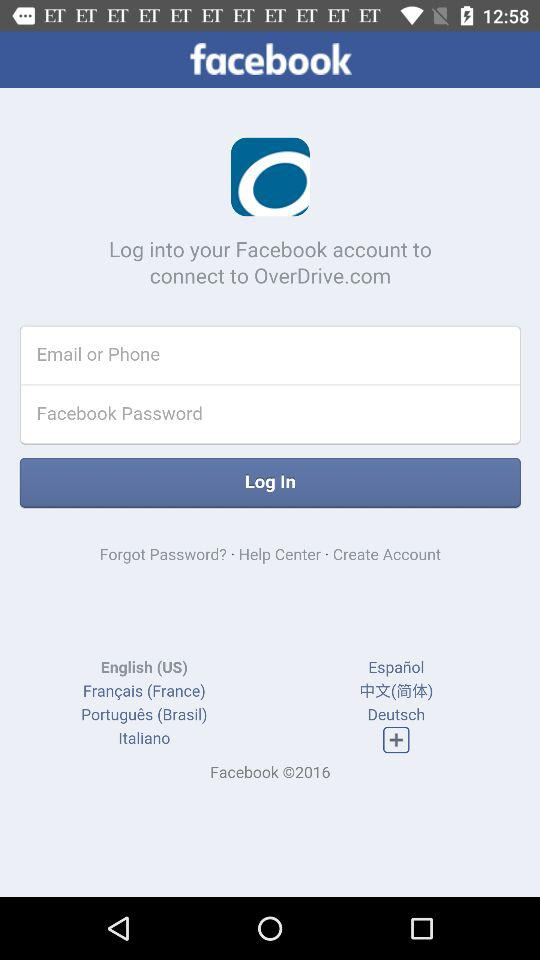Can we reset password?
When the provided information is insufficient, respond with <no answer>. <no answer> 